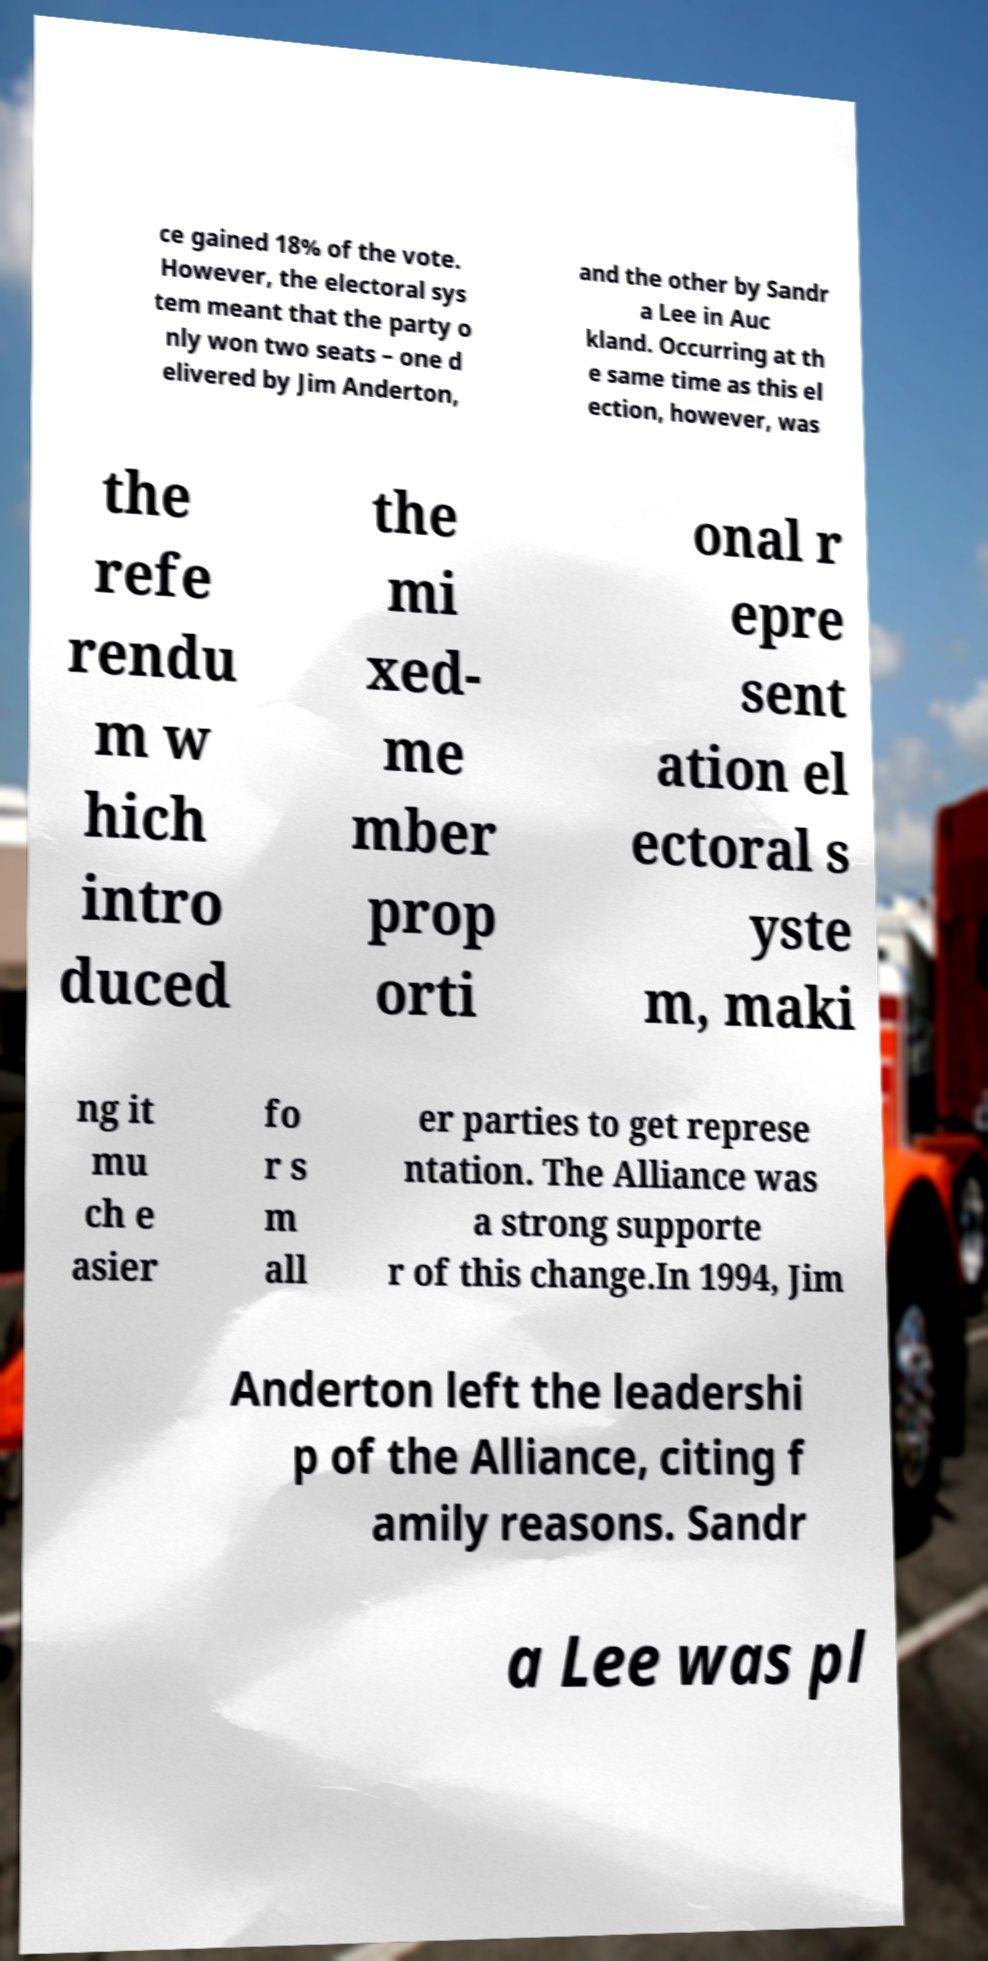I need the written content from this picture converted into text. Can you do that? ce gained 18% of the vote. However, the electoral sys tem meant that the party o nly won two seats – one d elivered by Jim Anderton, and the other by Sandr a Lee in Auc kland. Occurring at th e same time as this el ection, however, was the refe rendu m w hich intro duced the mi xed- me mber prop orti onal r epre sent ation el ectoral s yste m, maki ng it mu ch e asier fo r s m all er parties to get represe ntation. The Alliance was a strong supporte r of this change.In 1994, Jim Anderton left the leadershi p of the Alliance, citing f amily reasons. Sandr a Lee was pl 